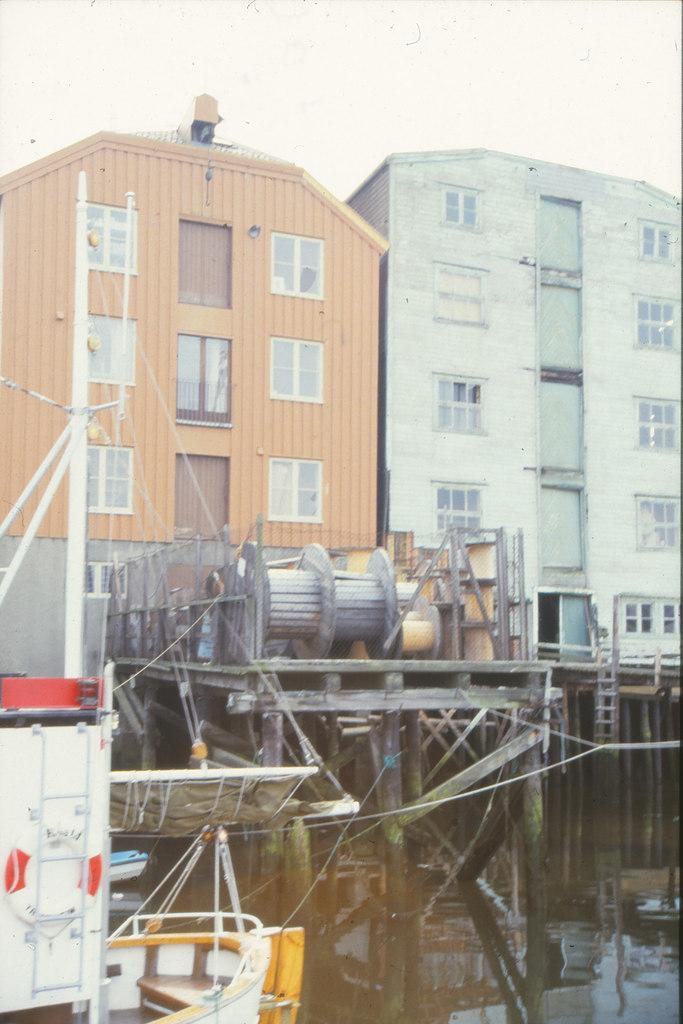What can be seen in the sky in the image? There is sky visible in the image. What type of structures are present in the image? There are buildings in the image. What piece of equipment is present in the image? There is a generator in the image. What natural element is visible in the image? There is water visible in the image. What type of mechanical devices are present in the image? There are machines in the image. Can you see any fish swimming in the water in the image? There are no fish visible in the image; only water is present. Are there any people fighting in the image? There is no fighting or any indication of conflict in the image. 